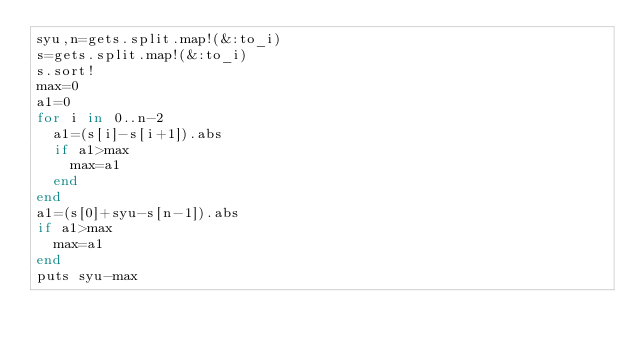Convert code to text. <code><loc_0><loc_0><loc_500><loc_500><_Ruby_>syu,n=gets.split.map!(&:to_i)
s=gets.split.map!(&:to_i)
s.sort!
max=0
a1=0
for i in 0..n-2
  a1=(s[i]-s[i+1]).abs
  if a1>max
    max=a1
  end
end
a1=(s[0]+syu-s[n-1]).abs
if a1>max
  max=a1
end
puts syu-max
</code> 